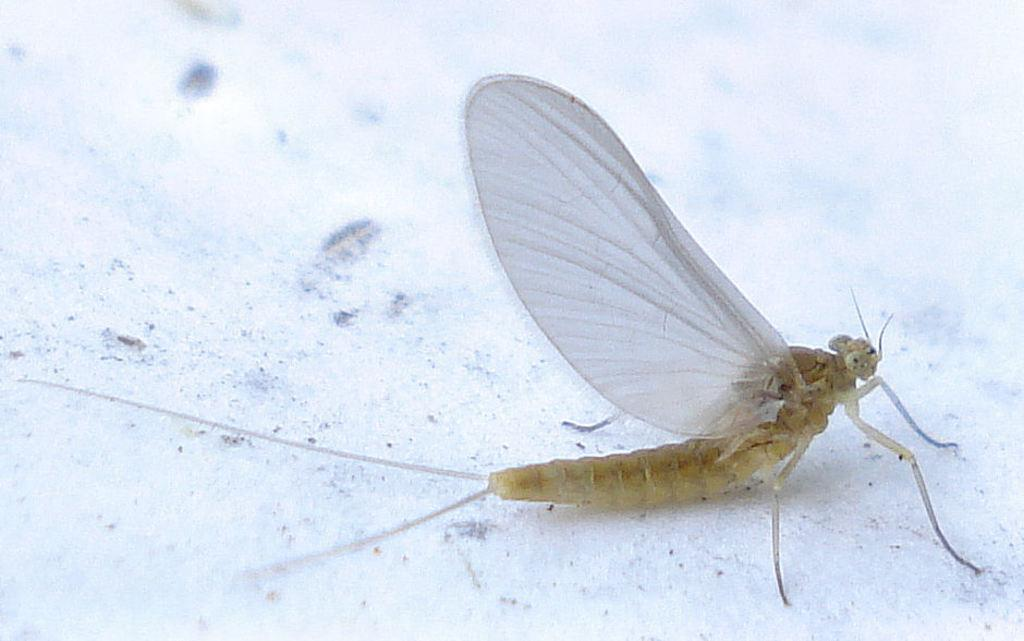What type of creature can be seen in the image? There is an insect in the image. What is the color of the surface where the insect is located? The insect is on a white colored surface. What type of rake is the insect using to gather the powder in the image? There is no rake or powder present in the image; it only features an insect on a white surface. 